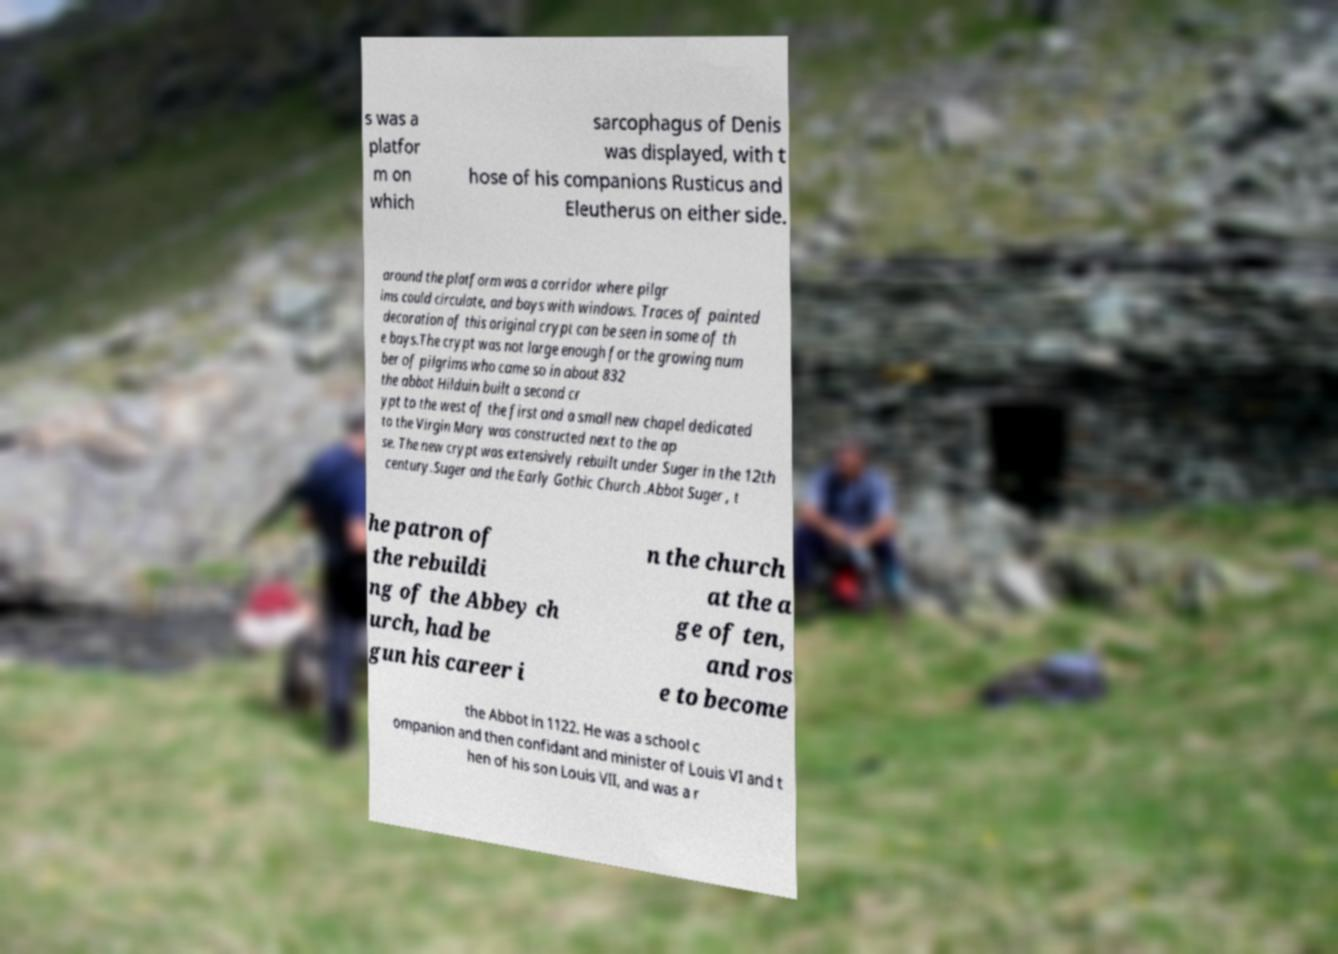Please read and relay the text visible in this image. What does it say? s was a platfor m on which sarcophagus of Denis was displayed, with t hose of his companions Rusticus and Eleutherus on either side. around the platform was a corridor where pilgr ims could circulate, and bays with windows. Traces of painted decoration of this original crypt can be seen in some of th e bays.The crypt was not large enough for the growing num ber of pilgrims who came so in about 832 the abbot Hilduin built a second cr ypt to the west of the first and a small new chapel dedicated to the Virgin Mary was constructed next to the ap se. The new crypt was extensively rebuilt under Suger in the 12th century.Suger and the Early Gothic Church .Abbot Suger , t he patron of the rebuildi ng of the Abbey ch urch, had be gun his career i n the church at the a ge of ten, and ros e to become the Abbot in 1122. He was a school c ompanion and then confidant and minister of Louis VI and t hen of his son Louis VII, and was a r 